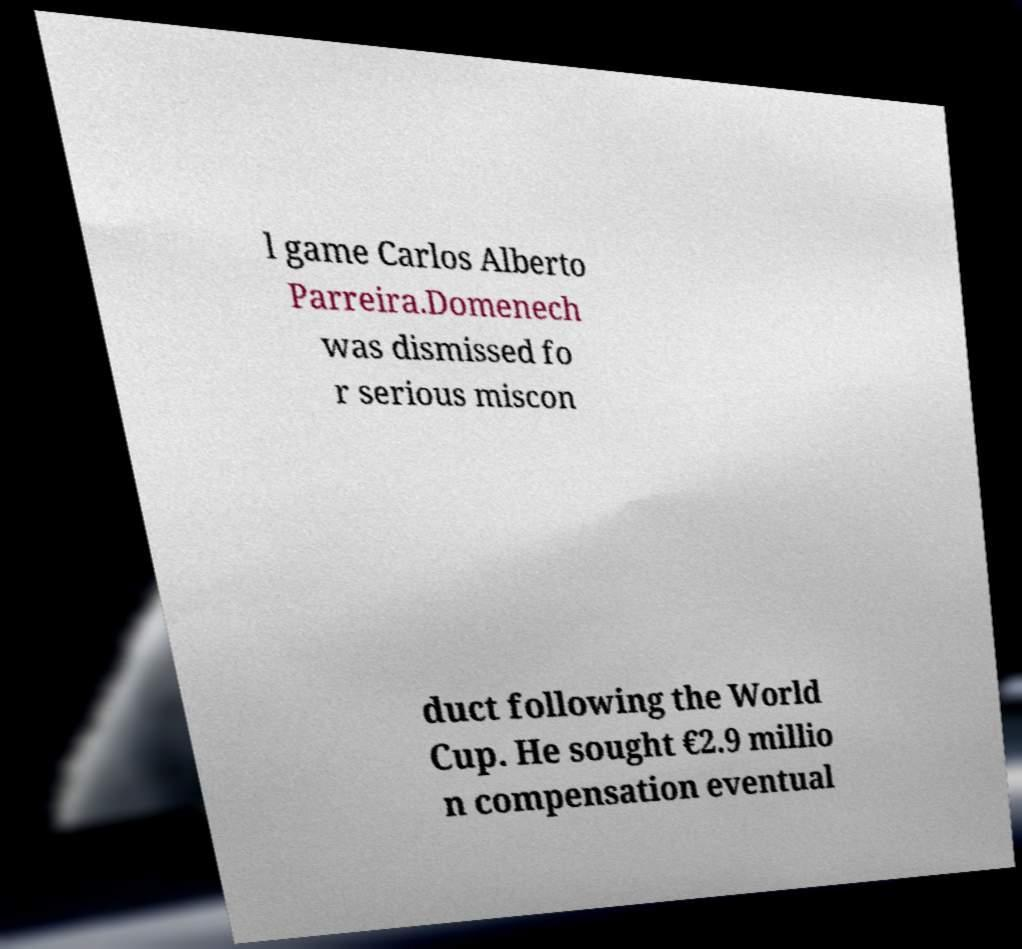For documentation purposes, I need the text within this image transcribed. Could you provide that? l game Carlos Alberto Parreira.Domenech was dismissed fo r serious miscon duct following the World Cup. He sought €2.9 millio n compensation eventual 